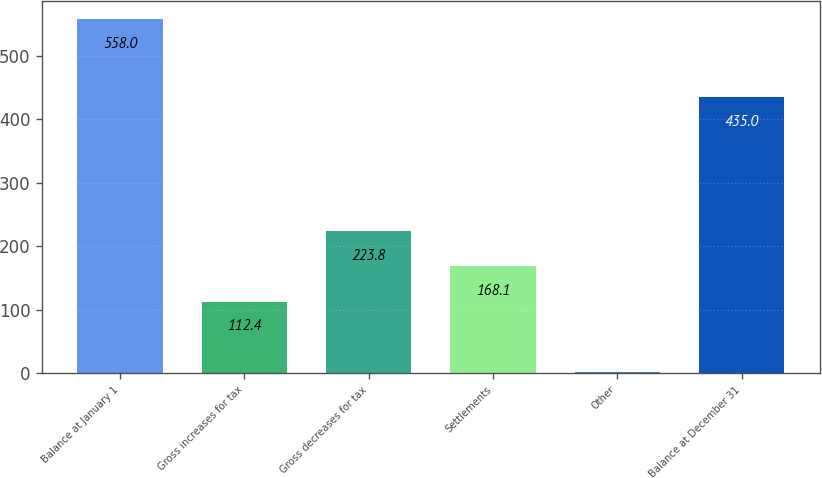Convert chart to OTSL. <chart><loc_0><loc_0><loc_500><loc_500><bar_chart><fcel>Balance at January 1<fcel>Gross increases for tax<fcel>Gross decreases for tax<fcel>Settlements<fcel>Other<fcel>Balance at December 31<nl><fcel>558<fcel>112.4<fcel>223.8<fcel>168.1<fcel>1<fcel>435<nl></chart> 